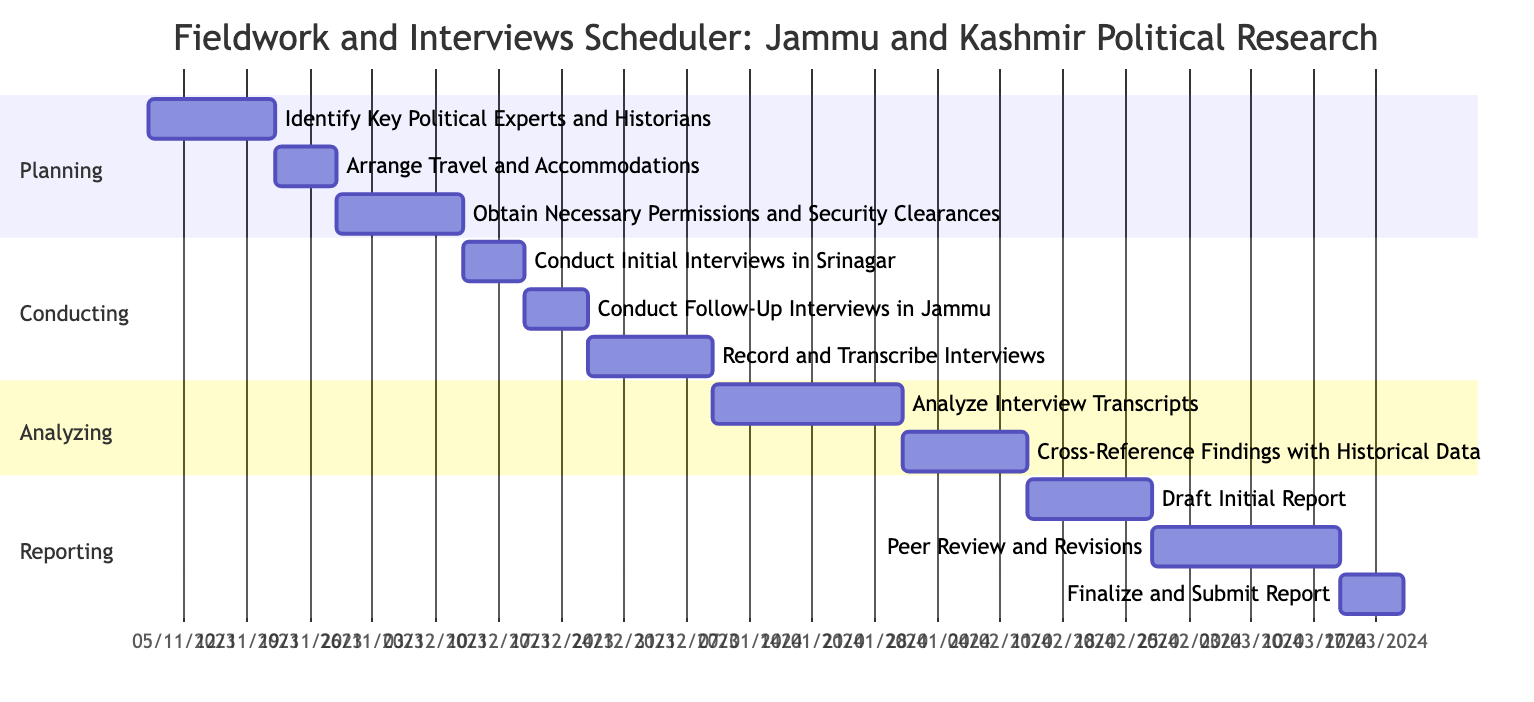What is the duration for identifying key political experts and historians? The task "Identify Key Political Experts and Historians" has a specified duration of "2 weeks" in the Gantt chart.
Answer: 2 weeks When does the task for obtaining necessary permissions and security clearances start? The task "Obtain Necessary Permissions and Security Clearances" starts on "2023-11-22" according to the timeline in the diagram.
Answer: 2023-11-22 How many tasks are there in the Conducting section? The Conducting section has three distinct tasks listed in the Gantt chart, which are "Conduct Initial Interviews in Srinagar," "Conduct Follow-Up Interviews in Jammu," and "Record and Transcribe Interviews."
Answer: 3 What is the total duration for the Reporting phase? The Reporting section includes three tasks with the following durations: 2 weeks for "Draft Initial Report," 3 weeks for "Peer Review and Revisions," and 1 week for "Finalize and Submit Report." Adding these durations gives a total of 6 weeks.
Answer: 6 weeks Which task directly follows "Conduct Initial Interviews in Srinagar"? The next task after "Conduct Initial Interviews in Srinagar," based on the timeline is "Conduct Follow-Up Interviews in Jammu." This is determined by looking at the sequence of tasks in the Conducting section.
Answer: Conduct Follow-Up Interviews in Jammu What are the start and end dates for the task "Record and Transcribe Interviews"? The task "Record and Transcribe Interviews" starts on "2023-12-20" and ends on "2024-01-02" as indicated in its section of the Gantt chart.
Answer: 2023-12-20 to 2024-01-02 Which section of the Gantt chart contains the task with the longest duration? The "Analyzing" section contains the task "Analyze Interview Transcripts," which has the longest duration of "3 weeks" when comparing with other tasks in the diagram.
Answer: Analyzing What is the overlapping duration, if any, between Analyzing and Reporting sections? The Analyzing section ends on "2024-02-06," and the Reporting section starts on "2024-02-07." There are no overlapping dates as Section A ends a day before Section R starts.
Answer: No overlapping 